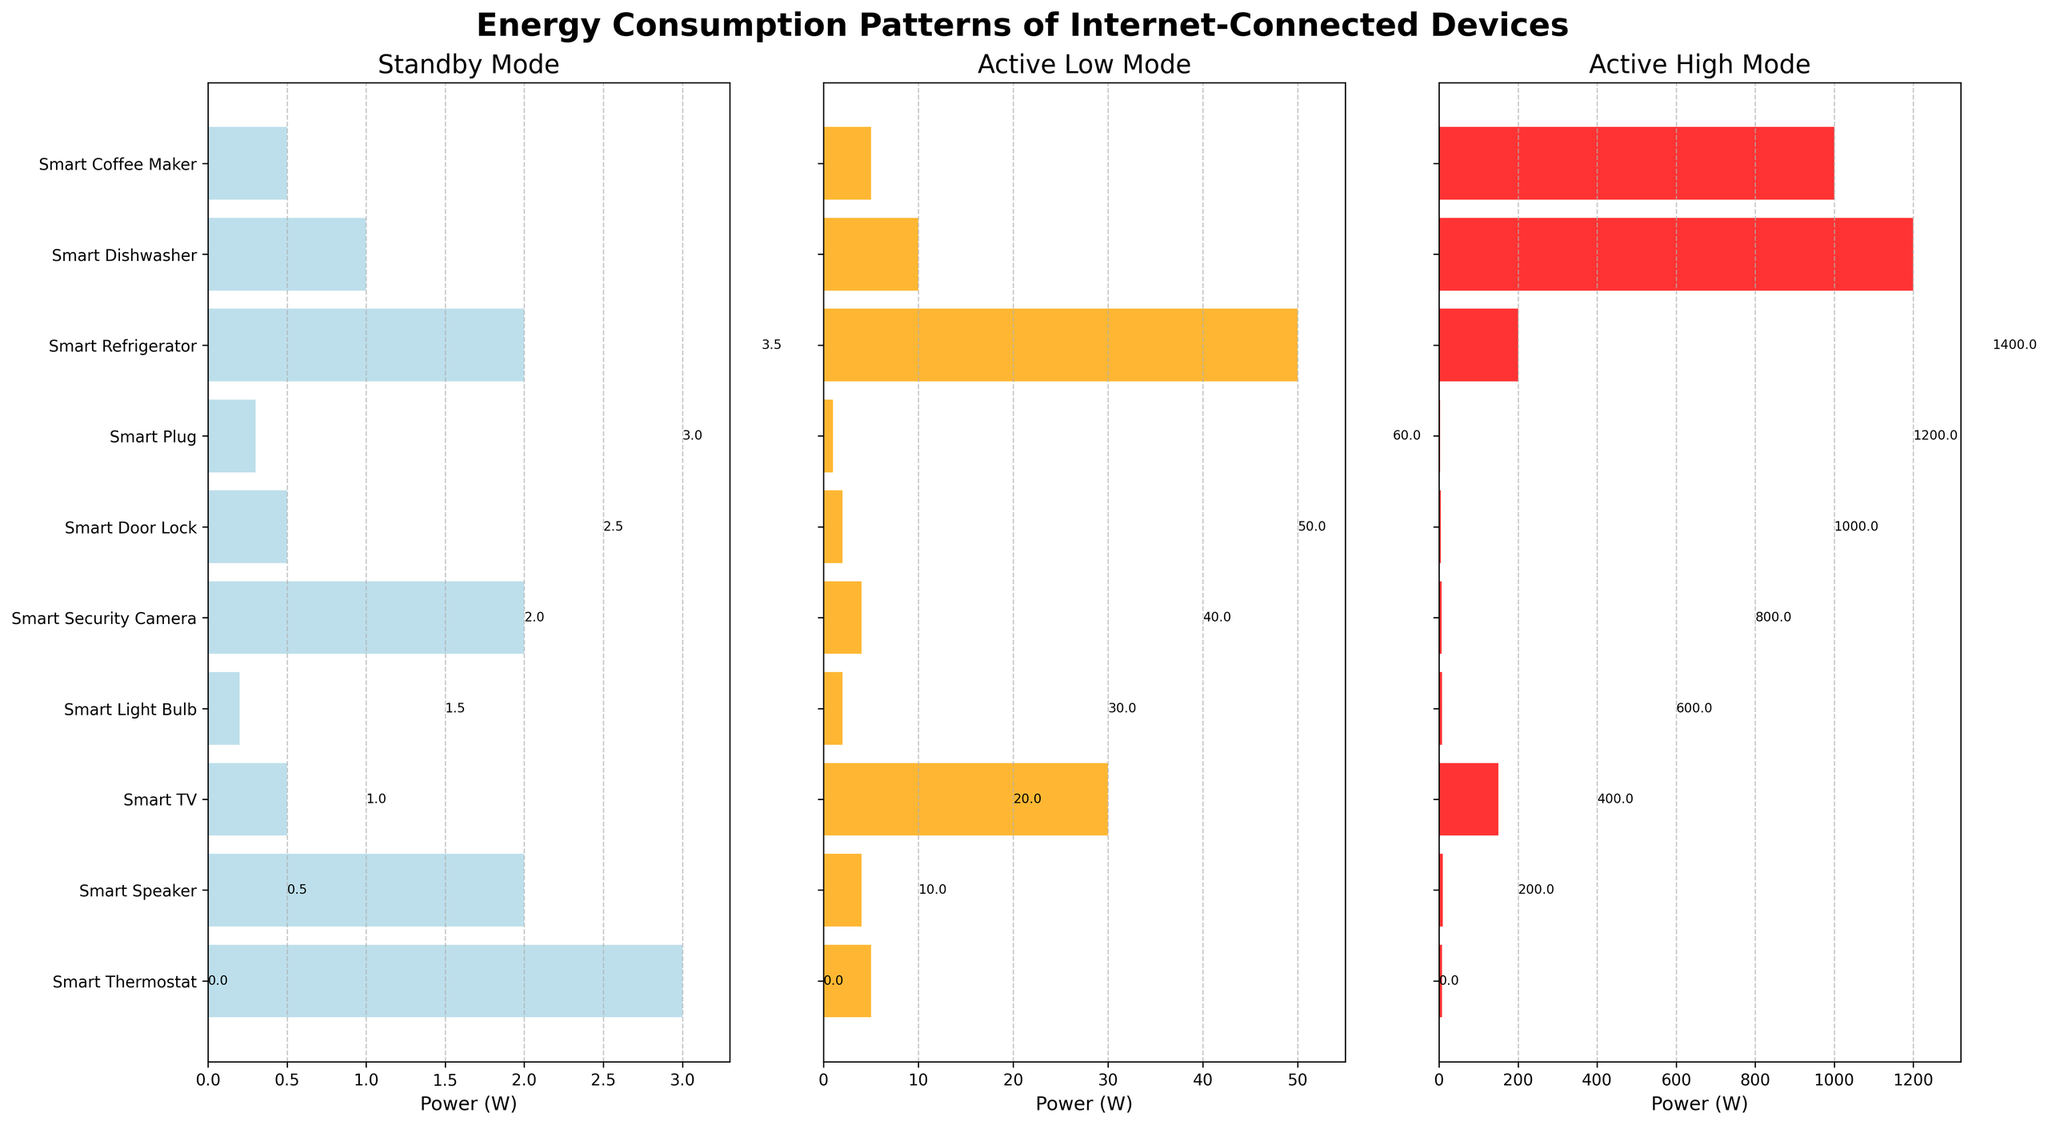What is the power consumption of the Smart Thermostat in standby mode? The power consumption of the Smart Thermostat in standby mode can be found by looking at the first bar in the first subplot (Standby Mode).
Answer: 3W Which device has the highest power consumption in active high mode? The highest bar in the third subplot (Active High Mode) represents the Smart Dishwasher.
Answer: Smart Dishwasher Compare the standby power consumption of Smart TV and Smart Light Bulb. Which one is higher and by how much? In the first subplot (Standby Mode), the Smart TV has a bar of 0.5W and the Smart Light Bulb has a bar of 0.2W. The difference between them is 0.5W - 0.2W = 0.3W.
Answer: Smart TV by 0.3W What is the total power consumption of the Smart Refrigerator in all modes? Sum up the Smart Refrigerator's power consumption in all subplots: 2W (Standby) + 50W (Active Low) + 200W (Active High) = 252W.
Answer: 252W Which device has the lowest power consumption in active low mode? The smallest bar in the second subplot (Active Low Mode) belongs to Smart Plug.
Answer: Smart Plug How much more power does the Smart Dishwasher consume in active high mode compared to active low mode? In the Active High Mode, the Smart Dishwasher consumes 1200W, and in the Active Low Mode, it consumes 10W. The difference is 1200W - 10W = 1190W.
Answer: 1190W What is the average power consumption in standby mode across all devices? Add all the power consumptions in standby mode and divide by the number of devices: (3 + 2 + 0.5 + 0.2 + 2 + 0.5 + 0.3 + 2 + 1 + 0.5) / 10 = 12.7 / 10 = 1.27W.
Answer: 1.27W Is there any device that consumes the same power in both standby and active low mode? Compare each device's power consumption in standby and active low modes. The Smart Speaker consumes 2W in standby and 4W in active low; no device matches in both modes.
Answer: No How does the power consumption of smart devices in active high mode compare to active low mode overall? Generally, the power consumption in active high mode is significantly higher than in active low mode, as indicated by the taller bars in the third subplot compared to the second subplot.
Answer: Higher overall What is the range of power consumption in active high mode for all devices? Subtract the smallest value in the Active High Mode from the largest value: 200W (highest for Smart Refrigerator) - 3W (lowest for Smart Plug) = 197W.
Answer: 197W 